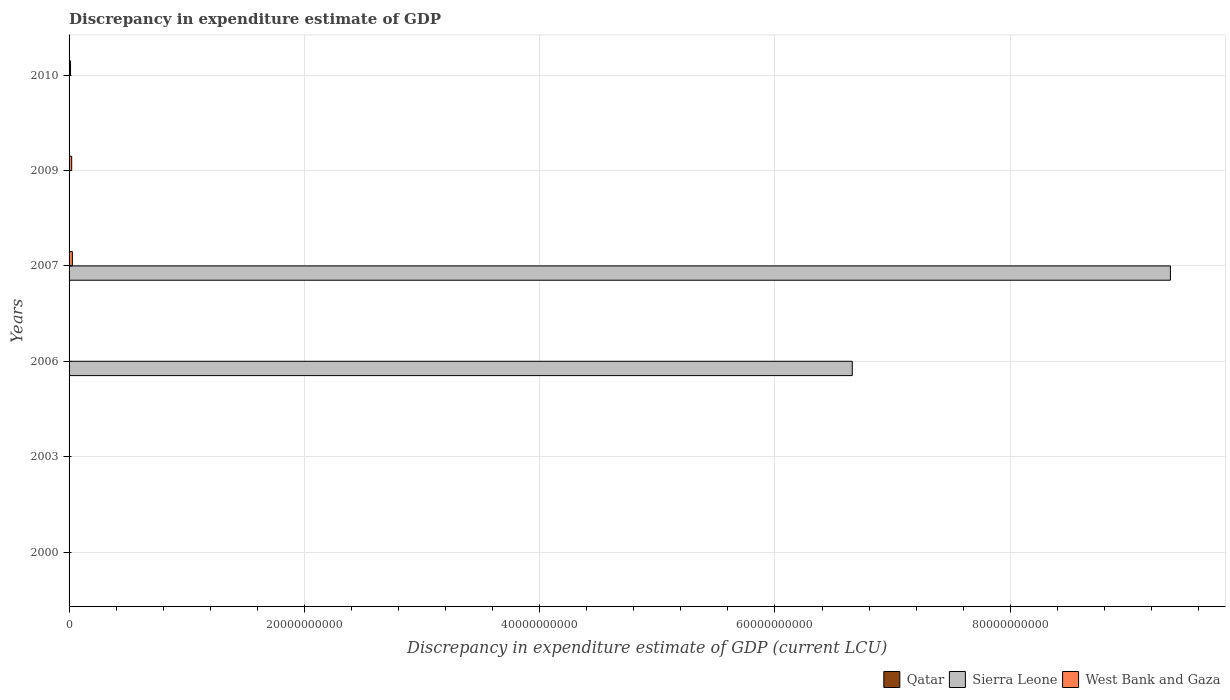How many bars are there on the 5th tick from the top?
Give a very brief answer. 1. How many bars are there on the 5th tick from the bottom?
Ensure brevity in your answer.  2. What is the discrepancy in expenditure estimate of GDP in Sierra Leone in 2007?
Provide a succinct answer. 9.36e+1. Across all years, what is the maximum discrepancy in expenditure estimate of GDP in Qatar?
Offer a very short reply. 2.00e+06. In which year was the discrepancy in expenditure estimate of GDP in Sierra Leone maximum?
Ensure brevity in your answer.  2007. What is the total discrepancy in expenditure estimate of GDP in Sierra Leone in the graph?
Keep it short and to the point. 1.60e+11. What is the difference between the discrepancy in expenditure estimate of GDP in Qatar in 2000 and that in 2009?
Give a very brief answer. -1.00e+06. What is the average discrepancy in expenditure estimate of GDP in Qatar per year?
Offer a very short reply. 5.33e+05. In the year 2009, what is the difference between the discrepancy in expenditure estimate of GDP in West Bank and Gaza and discrepancy in expenditure estimate of GDP in Qatar?
Make the answer very short. 2.21e+08. What is the ratio of the discrepancy in expenditure estimate of GDP in West Bank and Gaza in 2006 to that in 2007?
Your answer should be very brief. 0.12. Is the discrepancy in expenditure estimate of GDP in Qatar in 2003 less than that in 2010?
Ensure brevity in your answer.  No. What is the difference between the highest and the second highest discrepancy in expenditure estimate of GDP in Qatar?
Your answer should be very brief. 1.00e+06. What is the difference between the highest and the lowest discrepancy in expenditure estimate of GDP in Qatar?
Your answer should be compact. 2.00e+06. In how many years, is the discrepancy in expenditure estimate of GDP in Sierra Leone greater than the average discrepancy in expenditure estimate of GDP in Sierra Leone taken over all years?
Keep it short and to the point. 2. Is the sum of the discrepancy in expenditure estimate of GDP in West Bank and Gaza in 2007 and 2010 greater than the maximum discrepancy in expenditure estimate of GDP in Sierra Leone across all years?
Provide a succinct answer. No. Is it the case that in every year, the sum of the discrepancy in expenditure estimate of GDP in Sierra Leone and discrepancy in expenditure estimate of GDP in Qatar is greater than the discrepancy in expenditure estimate of GDP in West Bank and Gaza?
Your response must be concise. No. How many bars are there?
Provide a succinct answer. 10. Are all the bars in the graph horizontal?
Your answer should be compact. Yes. Does the graph contain any zero values?
Your response must be concise. Yes. Does the graph contain grids?
Provide a succinct answer. Yes. How many legend labels are there?
Ensure brevity in your answer.  3. How are the legend labels stacked?
Your response must be concise. Horizontal. What is the title of the graph?
Provide a short and direct response. Discrepancy in expenditure estimate of GDP. Does "Iraq" appear as one of the legend labels in the graph?
Provide a short and direct response. No. What is the label or title of the X-axis?
Make the answer very short. Discrepancy in expenditure estimate of GDP (current LCU). What is the label or title of the Y-axis?
Your answer should be very brief. Years. What is the Discrepancy in expenditure estimate of GDP (current LCU) in Qatar in 2000?
Offer a very short reply. 2e-6. What is the Discrepancy in expenditure estimate of GDP (current LCU) of Sierra Leone in 2000?
Your answer should be compact. 0. What is the Discrepancy in expenditure estimate of GDP (current LCU) of Qatar in 2003?
Provide a short and direct response. 2.00e+06. What is the Discrepancy in expenditure estimate of GDP (current LCU) of Sierra Leone in 2006?
Make the answer very short. 6.66e+1. What is the Discrepancy in expenditure estimate of GDP (current LCU) of West Bank and Gaza in 2006?
Ensure brevity in your answer.  3.30e+07. What is the Discrepancy in expenditure estimate of GDP (current LCU) in Sierra Leone in 2007?
Ensure brevity in your answer.  9.36e+1. What is the Discrepancy in expenditure estimate of GDP (current LCU) in West Bank and Gaza in 2007?
Ensure brevity in your answer.  2.81e+08. What is the Discrepancy in expenditure estimate of GDP (current LCU) in Qatar in 2009?
Ensure brevity in your answer.  1.00e+06. What is the Discrepancy in expenditure estimate of GDP (current LCU) of Sierra Leone in 2009?
Your answer should be very brief. 0. What is the Discrepancy in expenditure estimate of GDP (current LCU) of West Bank and Gaza in 2009?
Your response must be concise. 2.22e+08. What is the Discrepancy in expenditure estimate of GDP (current LCU) of Qatar in 2010?
Provide a succinct answer. 1.95e+05. What is the Discrepancy in expenditure estimate of GDP (current LCU) in Sierra Leone in 2010?
Provide a short and direct response. 0. What is the Discrepancy in expenditure estimate of GDP (current LCU) of West Bank and Gaza in 2010?
Ensure brevity in your answer.  1.23e+08. Across all years, what is the maximum Discrepancy in expenditure estimate of GDP (current LCU) of Qatar?
Provide a succinct answer. 2.00e+06. Across all years, what is the maximum Discrepancy in expenditure estimate of GDP (current LCU) of Sierra Leone?
Make the answer very short. 9.36e+1. Across all years, what is the maximum Discrepancy in expenditure estimate of GDP (current LCU) of West Bank and Gaza?
Provide a short and direct response. 2.81e+08. Across all years, what is the minimum Discrepancy in expenditure estimate of GDP (current LCU) in West Bank and Gaza?
Keep it short and to the point. 0. What is the total Discrepancy in expenditure estimate of GDP (current LCU) in Qatar in the graph?
Keep it short and to the point. 3.20e+06. What is the total Discrepancy in expenditure estimate of GDP (current LCU) in Sierra Leone in the graph?
Your response must be concise. 1.60e+11. What is the total Discrepancy in expenditure estimate of GDP (current LCU) in West Bank and Gaza in the graph?
Offer a very short reply. 6.59e+08. What is the difference between the Discrepancy in expenditure estimate of GDP (current LCU) of Qatar in 2000 and that in 2009?
Your response must be concise. -1.00e+06. What is the difference between the Discrepancy in expenditure estimate of GDP (current LCU) of Qatar in 2000 and that in 2010?
Provide a short and direct response. -1.95e+05. What is the difference between the Discrepancy in expenditure estimate of GDP (current LCU) of Qatar in 2003 and that in 2009?
Keep it short and to the point. 1.00e+06. What is the difference between the Discrepancy in expenditure estimate of GDP (current LCU) of Qatar in 2003 and that in 2010?
Keep it short and to the point. 1.80e+06. What is the difference between the Discrepancy in expenditure estimate of GDP (current LCU) in Sierra Leone in 2006 and that in 2007?
Offer a terse response. -2.70e+1. What is the difference between the Discrepancy in expenditure estimate of GDP (current LCU) in West Bank and Gaza in 2006 and that in 2007?
Make the answer very short. -2.48e+08. What is the difference between the Discrepancy in expenditure estimate of GDP (current LCU) of West Bank and Gaza in 2006 and that in 2009?
Ensure brevity in your answer.  -1.89e+08. What is the difference between the Discrepancy in expenditure estimate of GDP (current LCU) of West Bank and Gaza in 2006 and that in 2010?
Make the answer very short. -9.05e+07. What is the difference between the Discrepancy in expenditure estimate of GDP (current LCU) in West Bank and Gaza in 2007 and that in 2009?
Your response must be concise. 5.85e+07. What is the difference between the Discrepancy in expenditure estimate of GDP (current LCU) of West Bank and Gaza in 2007 and that in 2010?
Give a very brief answer. 1.57e+08. What is the difference between the Discrepancy in expenditure estimate of GDP (current LCU) of Qatar in 2009 and that in 2010?
Make the answer very short. 8.05e+05. What is the difference between the Discrepancy in expenditure estimate of GDP (current LCU) in West Bank and Gaza in 2009 and that in 2010?
Your answer should be very brief. 9.88e+07. What is the difference between the Discrepancy in expenditure estimate of GDP (current LCU) of Qatar in 2000 and the Discrepancy in expenditure estimate of GDP (current LCU) of Sierra Leone in 2006?
Provide a succinct answer. -6.66e+1. What is the difference between the Discrepancy in expenditure estimate of GDP (current LCU) of Qatar in 2000 and the Discrepancy in expenditure estimate of GDP (current LCU) of West Bank and Gaza in 2006?
Keep it short and to the point. -3.30e+07. What is the difference between the Discrepancy in expenditure estimate of GDP (current LCU) in Qatar in 2000 and the Discrepancy in expenditure estimate of GDP (current LCU) in Sierra Leone in 2007?
Your answer should be very brief. -9.36e+1. What is the difference between the Discrepancy in expenditure estimate of GDP (current LCU) of Qatar in 2000 and the Discrepancy in expenditure estimate of GDP (current LCU) of West Bank and Gaza in 2007?
Provide a succinct answer. -2.81e+08. What is the difference between the Discrepancy in expenditure estimate of GDP (current LCU) of Qatar in 2000 and the Discrepancy in expenditure estimate of GDP (current LCU) of West Bank and Gaza in 2009?
Ensure brevity in your answer.  -2.22e+08. What is the difference between the Discrepancy in expenditure estimate of GDP (current LCU) in Qatar in 2000 and the Discrepancy in expenditure estimate of GDP (current LCU) in West Bank and Gaza in 2010?
Give a very brief answer. -1.23e+08. What is the difference between the Discrepancy in expenditure estimate of GDP (current LCU) in Qatar in 2003 and the Discrepancy in expenditure estimate of GDP (current LCU) in Sierra Leone in 2006?
Provide a short and direct response. -6.66e+1. What is the difference between the Discrepancy in expenditure estimate of GDP (current LCU) of Qatar in 2003 and the Discrepancy in expenditure estimate of GDP (current LCU) of West Bank and Gaza in 2006?
Your answer should be compact. -3.10e+07. What is the difference between the Discrepancy in expenditure estimate of GDP (current LCU) in Qatar in 2003 and the Discrepancy in expenditure estimate of GDP (current LCU) in Sierra Leone in 2007?
Make the answer very short. -9.36e+1. What is the difference between the Discrepancy in expenditure estimate of GDP (current LCU) in Qatar in 2003 and the Discrepancy in expenditure estimate of GDP (current LCU) in West Bank and Gaza in 2007?
Keep it short and to the point. -2.79e+08. What is the difference between the Discrepancy in expenditure estimate of GDP (current LCU) of Qatar in 2003 and the Discrepancy in expenditure estimate of GDP (current LCU) of West Bank and Gaza in 2009?
Your answer should be compact. -2.20e+08. What is the difference between the Discrepancy in expenditure estimate of GDP (current LCU) of Qatar in 2003 and the Discrepancy in expenditure estimate of GDP (current LCU) of West Bank and Gaza in 2010?
Make the answer very short. -1.21e+08. What is the difference between the Discrepancy in expenditure estimate of GDP (current LCU) in Sierra Leone in 2006 and the Discrepancy in expenditure estimate of GDP (current LCU) in West Bank and Gaza in 2007?
Give a very brief answer. 6.63e+1. What is the difference between the Discrepancy in expenditure estimate of GDP (current LCU) of Sierra Leone in 2006 and the Discrepancy in expenditure estimate of GDP (current LCU) of West Bank and Gaza in 2009?
Provide a succinct answer. 6.63e+1. What is the difference between the Discrepancy in expenditure estimate of GDP (current LCU) in Sierra Leone in 2006 and the Discrepancy in expenditure estimate of GDP (current LCU) in West Bank and Gaza in 2010?
Your answer should be very brief. 6.64e+1. What is the difference between the Discrepancy in expenditure estimate of GDP (current LCU) in Sierra Leone in 2007 and the Discrepancy in expenditure estimate of GDP (current LCU) in West Bank and Gaza in 2009?
Make the answer very short. 9.34e+1. What is the difference between the Discrepancy in expenditure estimate of GDP (current LCU) in Sierra Leone in 2007 and the Discrepancy in expenditure estimate of GDP (current LCU) in West Bank and Gaza in 2010?
Your answer should be compact. 9.35e+1. What is the difference between the Discrepancy in expenditure estimate of GDP (current LCU) in Qatar in 2009 and the Discrepancy in expenditure estimate of GDP (current LCU) in West Bank and Gaza in 2010?
Your answer should be compact. -1.22e+08. What is the average Discrepancy in expenditure estimate of GDP (current LCU) of Qatar per year?
Offer a very short reply. 5.33e+05. What is the average Discrepancy in expenditure estimate of GDP (current LCU) in Sierra Leone per year?
Provide a succinct answer. 2.67e+1. What is the average Discrepancy in expenditure estimate of GDP (current LCU) in West Bank and Gaza per year?
Offer a very short reply. 1.10e+08. In the year 2006, what is the difference between the Discrepancy in expenditure estimate of GDP (current LCU) in Sierra Leone and Discrepancy in expenditure estimate of GDP (current LCU) in West Bank and Gaza?
Make the answer very short. 6.65e+1. In the year 2007, what is the difference between the Discrepancy in expenditure estimate of GDP (current LCU) in Sierra Leone and Discrepancy in expenditure estimate of GDP (current LCU) in West Bank and Gaza?
Offer a very short reply. 9.33e+1. In the year 2009, what is the difference between the Discrepancy in expenditure estimate of GDP (current LCU) of Qatar and Discrepancy in expenditure estimate of GDP (current LCU) of West Bank and Gaza?
Keep it short and to the point. -2.21e+08. In the year 2010, what is the difference between the Discrepancy in expenditure estimate of GDP (current LCU) in Qatar and Discrepancy in expenditure estimate of GDP (current LCU) in West Bank and Gaza?
Give a very brief answer. -1.23e+08. What is the ratio of the Discrepancy in expenditure estimate of GDP (current LCU) in Qatar in 2003 to that in 2010?
Make the answer very short. 10.25. What is the ratio of the Discrepancy in expenditure estimate of GDP (current LCU) in Sierra Leone in 2006 to that in 2007?
Give a very brief answer. 0.71. What is the ratio of the Discrepancy in expenditure estimate of GDP (current LCU) of West Bank and Gaza in 2006 to that in 2007?
Provide a succinct answer. 0.12. What is the ratio of the Discrepancy in expenditure estimate of GDP (current LCU) of West Bank and Gaza in 2006 to that in 2009?
Give a very brief answer. 0.15. What is the ratio of the Discrepancy in expenditure estimate of GDP (current LCU) in West Bank and Gaza in 2006 to that in 2010?
Offer a terse response. 0.27. What is the ratio of the Discrepancy in expenditure estimate of GDP (current LCU) of West Bank and Gaza in 2007 to that in 2009?
Your answer should be compact. 1.26. What is the ratio of the Discrepancy in expenditure estimate of GDP (current LCU) in West Bank and Gaza in 2007 to that in 2010?
Offer a very short reply. 2.27. What is the ratio of the Discrepancy in expenditure estimate of GDP (current LCU) in Qatar in 2009 to that in 2010?
Provide a short and direct response. 5.13. What is the ratio of the Discrepancy in expenditure estimate of GDP (current LCU) of West Bank and Gaza in 2009 to that in 2010?
Offer a very short reply. 1.8. What is the difference between the highest and the second highest Discrepancy in expenditure estimate of GDP (current LCU) in Qatar?
Give a very brief answer. 1.00e+06. What is the difference between the highest and the second highest Discrepancy in expenditure estimate of GDP (current LCU) of West Bank and Gaza?
Offer a terse response. 5.85e+07. What is the difference between the highest and the lowest Discrepancy in expenditure estimate of GDP (current LCU) in Qatar?
Make the answer very short. 2.00e+06. What is the difference between the highest and the lowest Discrepancy in expenditure estimate of GDP (current LCU) in Sierra Leone?
Provide a short and direct response. 9.36e+1. What is the difference between the highest and the lowest Discrepancy in expenditure estimate of GDP (current LCU) of West Bank and Gaza?
Provide a short and direct response. 2.81e+08. 